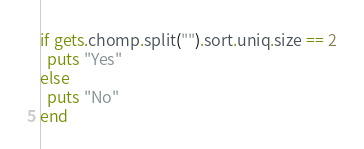Convert code to text. <code><loc_0><loc_0><loc_500><loc_500><_Ruby_>if gets.chomp.split("").sort.uniq.size == 2
  puts "Yes"
else
  puts "No"
end

</code> 